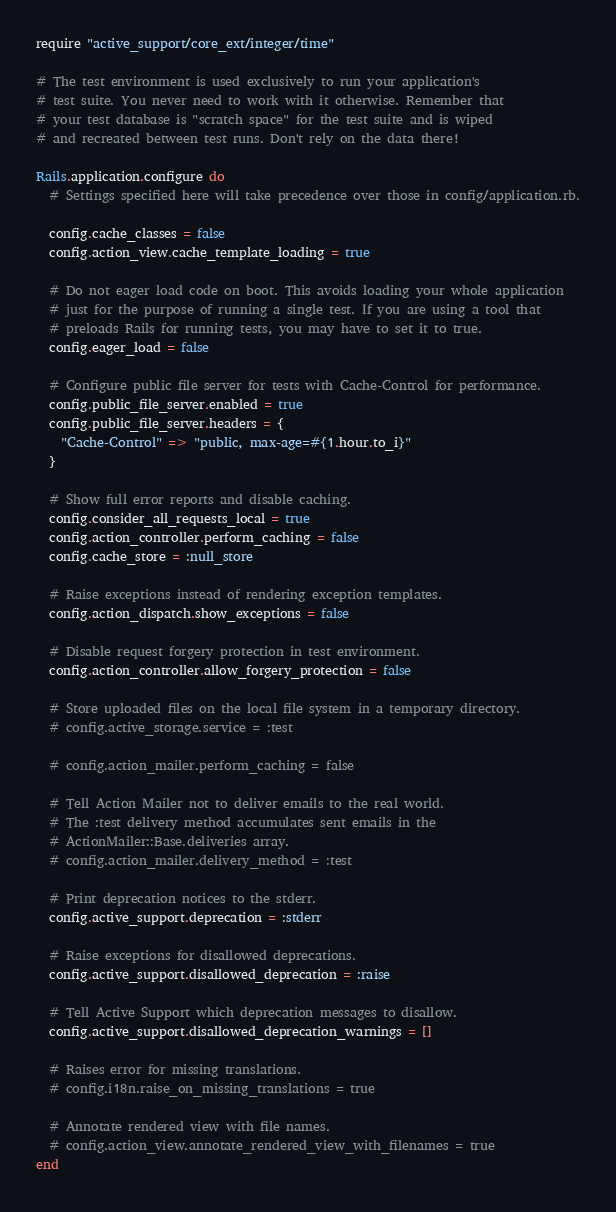Convert code to text. <code><loc_0><loc_0><loc_500><loc_500><_Ruby_>require "active_support/core_ext/integer/time"

# The test environment is used exclusively to run your application's
# test suite. You never need to work with it otherwise. Remember that
# your test database is "scratch space" for the test suite and is wiped
# and recreated between test runs. Don't rely on the data there!

Rails.application.configure do
  # Settings specified here will take precedence over those in config/application.rb.

  config.cache_classes = false
  config.action_view.cache_template_loading = true

  # Do not eager load code on boot. This avoids loading your whole application
  # just for the purpose of running a single test. If you are using a tool that
  # preloads Rails for running tests, you may have to set it to true.
  config.eager_load = false

  # Configure public file server for tests with Cache-Control for performance.
  config.public_file_server.enabled = true
  config.public_file_server.headers = {
    "Cache-Control" => "public, max-age=#{1.hour.to_i}"
  }

  # Show full error reports and disable caching.
  config.consider_all_requests_local = true
  config.action_controller.perform_caching = false
  config.cache_store = :null_store

  # Raise exceptions instead of rendering exception templates.
  config.action_dispatch.show_exceptions = false

  # Disable request forgery protection in test environment.
  config.action_controller.allow_forgery_protection = false

  # Store uploaded files on the local file system in a temporary directory.
  # config.active_storage.service = :test

  # config.action_mailer.perform_caching = false

  # Tell Action Mailer not to deliver emails to the real world.
  # The :test delivery method accumulates sent emails in the
  # ActionMailer::Base.deliveries array.
  # config.action_mailer.delivery_method = :test

  # Print deprecation notices to the stderr.
  config.active_support.deprecation = :stderr

  # Raise exceptions for disallowed deprecations.
  config.active_support.disallowed_deprecation = :raise

  # Tell Active Support which deprecation messages to disallow.
  config.active_support.disallowed_deprecation_warnings = []

  # Raises error for missing translations.
  # config.i18n.raise_on_missing_translations = true

  # Annotate rendered view with file names.
  # config.action_view.annotate_rendered_view_with_filenames = true
end
</code> 